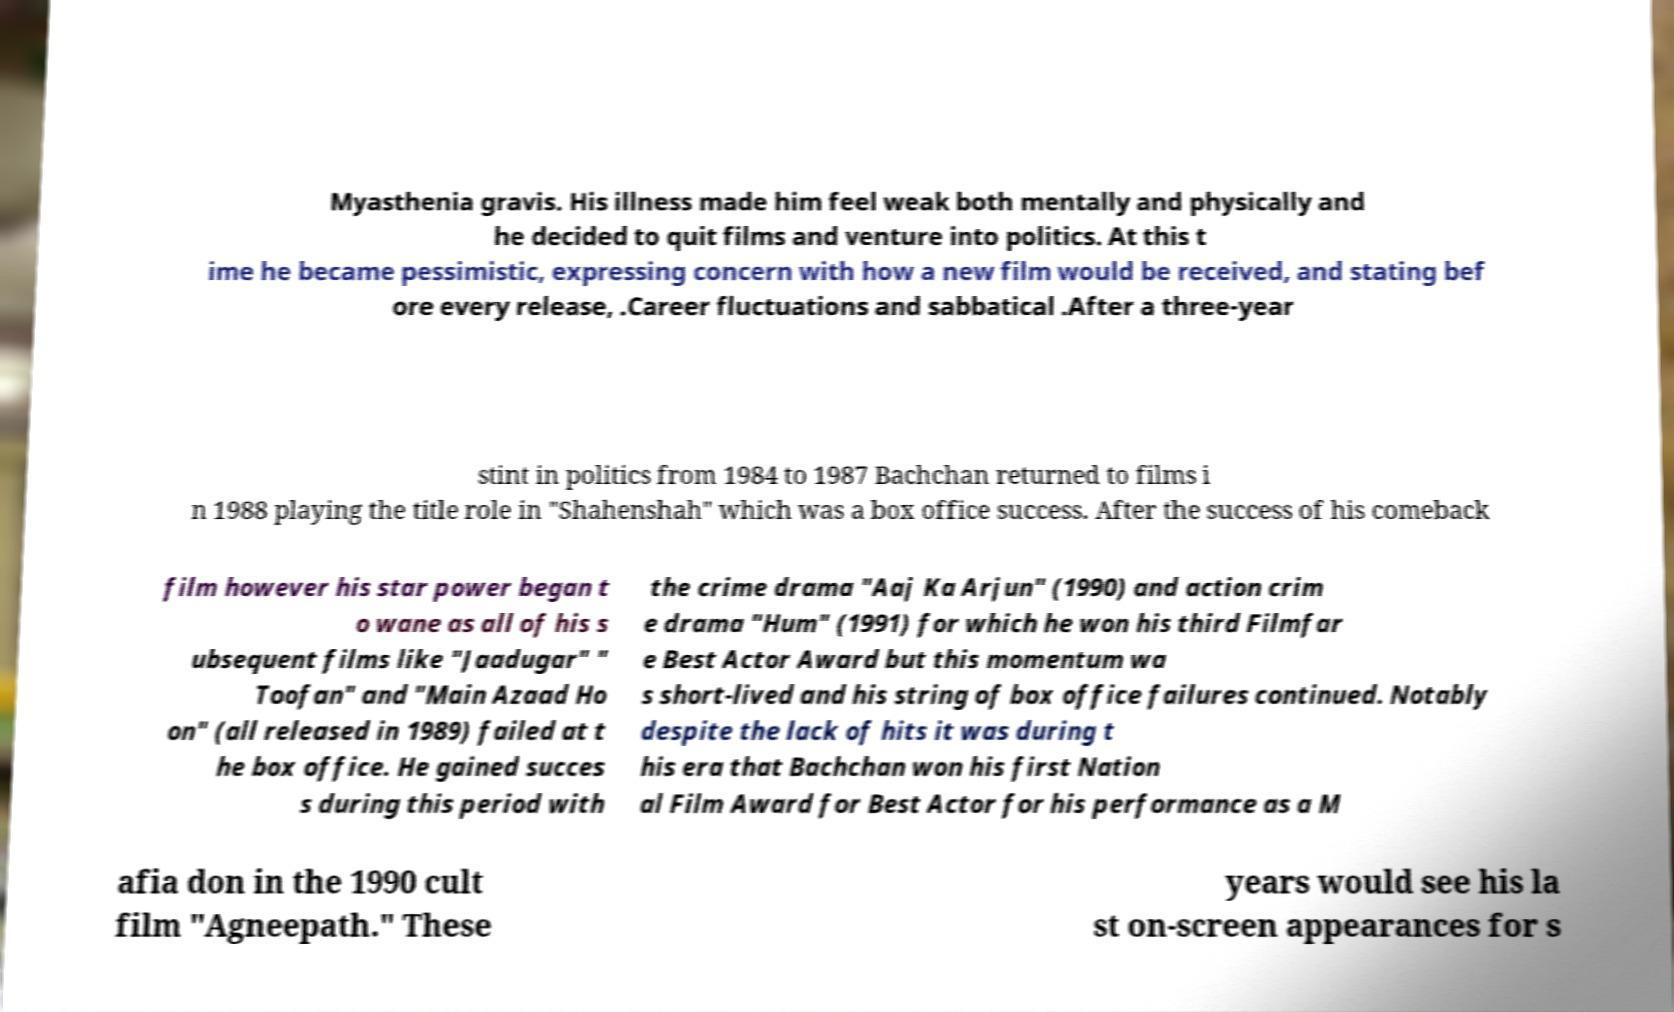Please read and relay the text visible in this image. What does it say? Myasthenia gravis. His illness made him feel weak both mentally and physically and he decided to quit films and venture into politics. At this t ime he became pessimistic, expressing concern with how a new film would be received, and stating bef ore every release, .Career fluctuations and sabbatical .After a three-year stint in politics from 1984 to 1987 Bachchan returned to films i n 1988 playing the title role in "Shahenshah" which was a box office success. After the success of his comeback film however his star power began t o wane as all of his s ubsequent films like "Jaadugar" " Toofan" and "Main Azaad Ho on" (all released in 1989) failed at t he box office. He gained succes s during this period with the crime drama "Aaj Ka Arjun" (1990) and action crim e drama "Hum" (1991) for which he won his third Filmfar e Best Actor Award but this momentum wa s short-lived and his string of box office failures continued. Notably despite the lack of hits it was during t his era that Bachchan won his first Nation al Film Award for Best Actor for his performance as a M afia don in the 1990 cult film "Agneepath." These years would see his la st on-screen appearances for s 